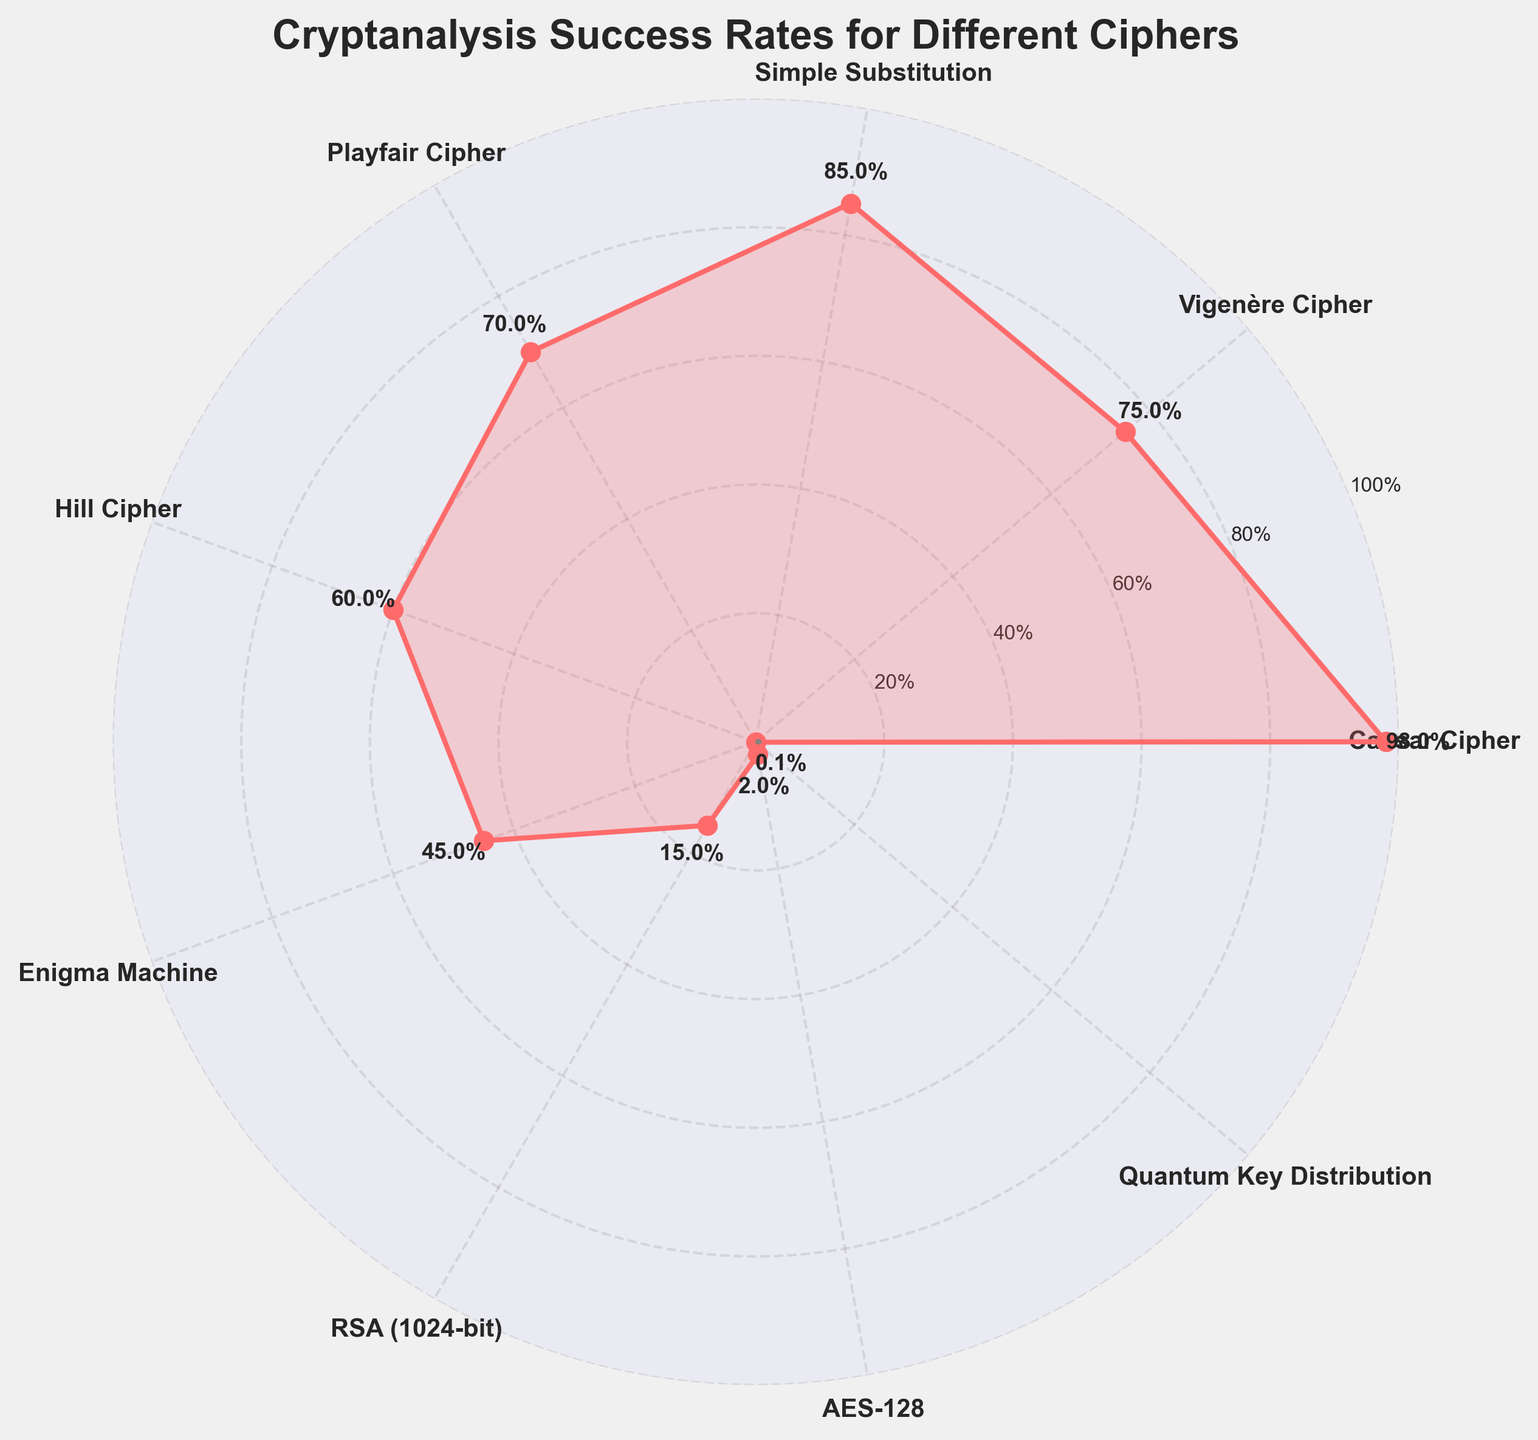What is the title of the figure? The title text is displayed at the top of the figure.
Answer: Cryptanalysis Success Rates for Different Ciphers Which cipher has the highest success rate according to the figure? By looking at the data points and their corresponding success rates, you can identify the highest value.
Answer: Caesar Cipher How many ciphers have a success rate of 70% or above? Count the data points with success rates of 70% or higher: Caesar Cipher (98%), Vigenère Cipher (75%), Simple Substitution (85%), and Playfair Cipher (70%).
Answer: 4 What is the average success rate of the Playfair Cipher, Hill Cipher, and Enigma Machine? Add the success rates of the Playfair Cipher (70%), Hill Cipher (60%), and Enigma Machine (45%) and then divide by 3. (70 + 60 + 45) / 3 = 175 / 3 ≈ 58.33
Answer: 58.33 How does the success rate of Quantum Key Distribution compare to that of AES-128? Compare the success rates of Quantum Key Distribution (0.1%) and AES-128 (2%).
Answer: Quantum Key Distribution has a lower success rate than AES-128 Which ciphers have a success rate less than 50%? Check the figure for ciphers with success rates below 50%. These are Enigma Machine (45%), RSA (1024-bit) (15%), AES-128 (2%), and Quantum Key Distribution (0.1%).
Answer: Enigma Machine, RSA (1024-bit), AES-128, Quantum Key Distribution If RSA (1024-bit) had its success rate increased by 10%, what would be the new success rate? Add 10% to the original success rate of RSA (1024-bit), which is 15%. 15% + 10% = 25%
Answer: 25% Which cipher has the lowest success rate, and what is that rate? Identify the cipher with the smallest value in the chart.
Answer: Quantum Key Distribution, 0.1% How much greater is the success rate of Simple Substitution compared to Playfair Cipher? Subtract the success rate of the Playfair Cipher (70%) from that of Simple Substitution (85%). 85% - 70% = 15%
Answer: 15% What's the range of success rates depicted in the figure? Subtract the smallest success rate (Quantum Key Distribution, 0.1%) from the highest success rate (Caesar Cipher, 98%). 98% - 0.1% = 97.9%
Answer: 97.9% 